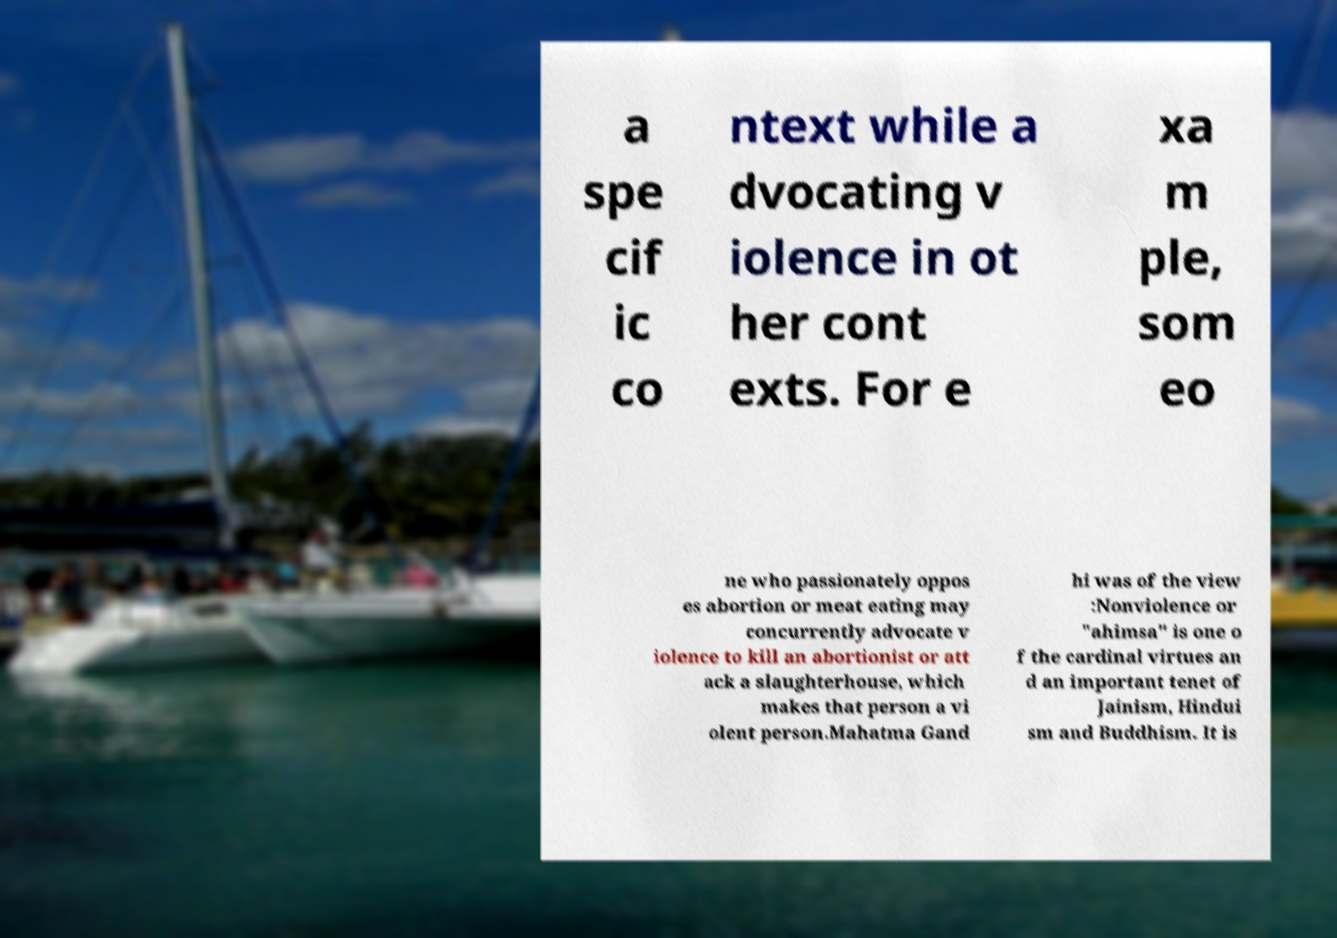Could you assist in decoding the text presented in this image and type it out clearly? a spe cif ic co ntext while a dvocating v iolence in ot her cont exts. For e xa m ple, som eo ne who passionately oppos es abortion or meat eating may concurrently advocate v iolence to kill an abortionist or att ack a slaughterhouse, which makes that person a vi olent person.Mahatma Gand hi was of the view :Nonviolence or "ahimsa" is one o f the cardinal virtues an d an important tenet of Jainism, Hindui sm and Buddhism. It is 